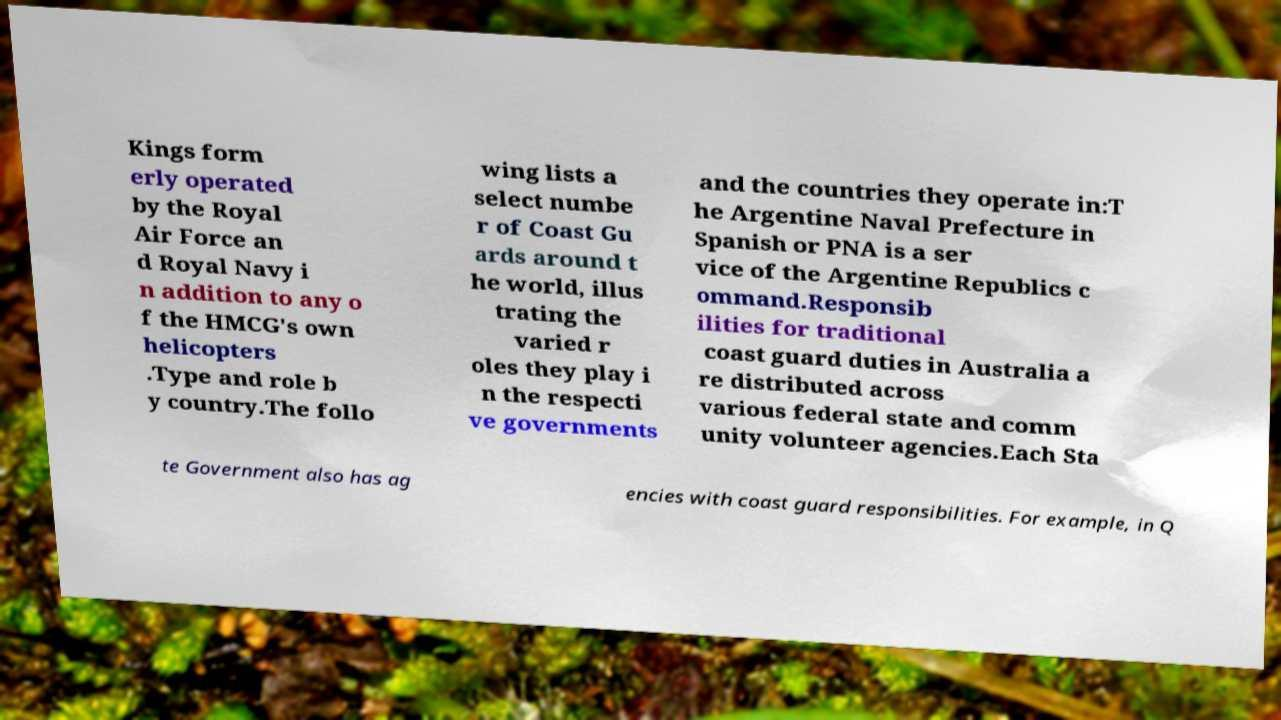Could you assist in decoding the text presented in this image and type it out clearly? Kings form erly operated by the Royal Air Force an d Royal Navy i n addition to any o f the HMCG's own helicopters .Type and role b y country.The follo wing lists a select numbe r of Coast Gu ards around t he world, illus trating the varied r oles they play i n the respecti ve governments and the countries they operate in:T he Argentine Naval Prefecture in Spanish or PNA is a ser vice of the Argentine Republics c ommand.Responsib ilities for traditional coast guard duties in Australia a re distributed across various federal state and comm unity volunteer agencies.Each Sta te Government also has ag encies with coast guard responsibilities. For example, in Q 